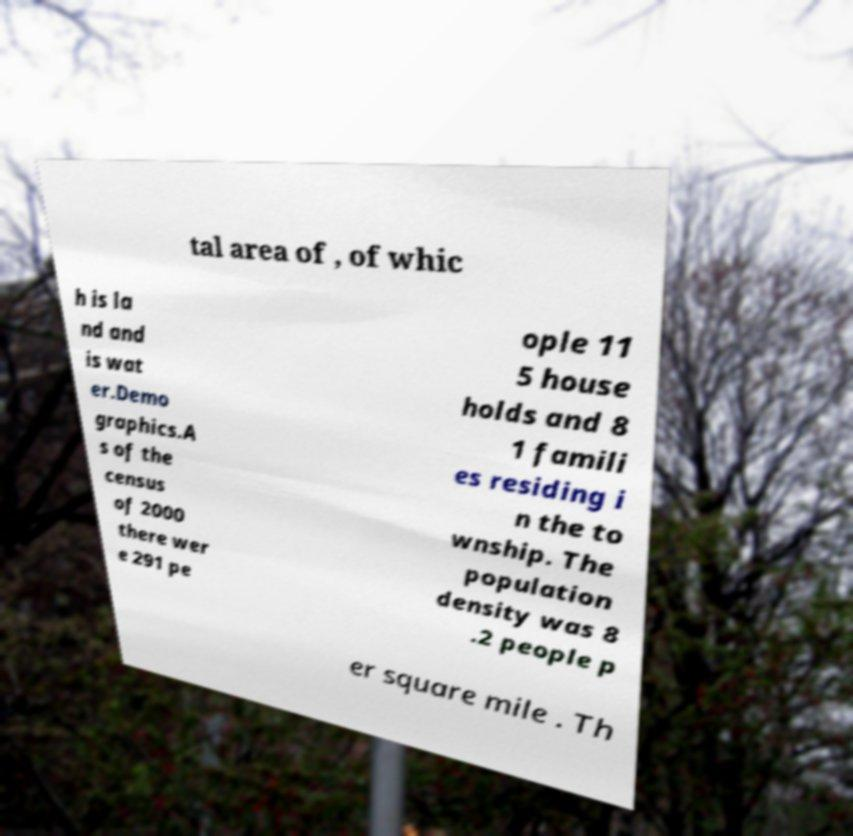For documentation purposes, I need the text within this image transcribed. Could you provide that? tal area of , of whic h is la nd and is wat er.Demo graphics.A s of the census of 2000 there wer e 291 pe ople 11 5 house holds and 8 1 famili es residing i n the to wnship. The population density was 8 .2 people p er square mile . Th 